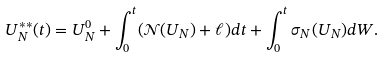Convert formula to latex. <formula><loc_0><loc_0><loc_500><loc_500>U ^ { * * } _ { N } ( t ) = U _ { N } ^ { 0 } + \int _ { 0 } ^ { t } ( \mathcal { N } ( U _ { N } ) + \ell ) d t + \int _ { 0 } ^ { t } \sigma _ { N } ( U _ { N } ) d W .</formula> 